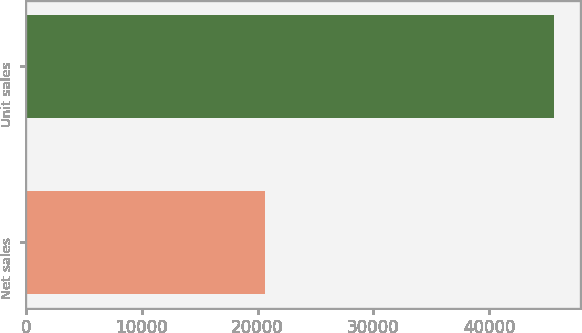Convert chart. <chart><loc_0><loc_0><loc_500><loc_500><bar_chart><fcel>Net sales<fcel>Unit sales<nl><fcel>20628<fcel>45590<nl></chart> 